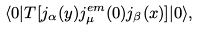Convert formula to latex. <formula><loc_0><loc_0><loc_500><loc_500>\langle 0 | T [ j _ { \alpha } ( y ) j ^ { e m } _ { \mu } ( 0 ) j _ { \beta } ( x ) ] | 0 \rangle ,</formula> 